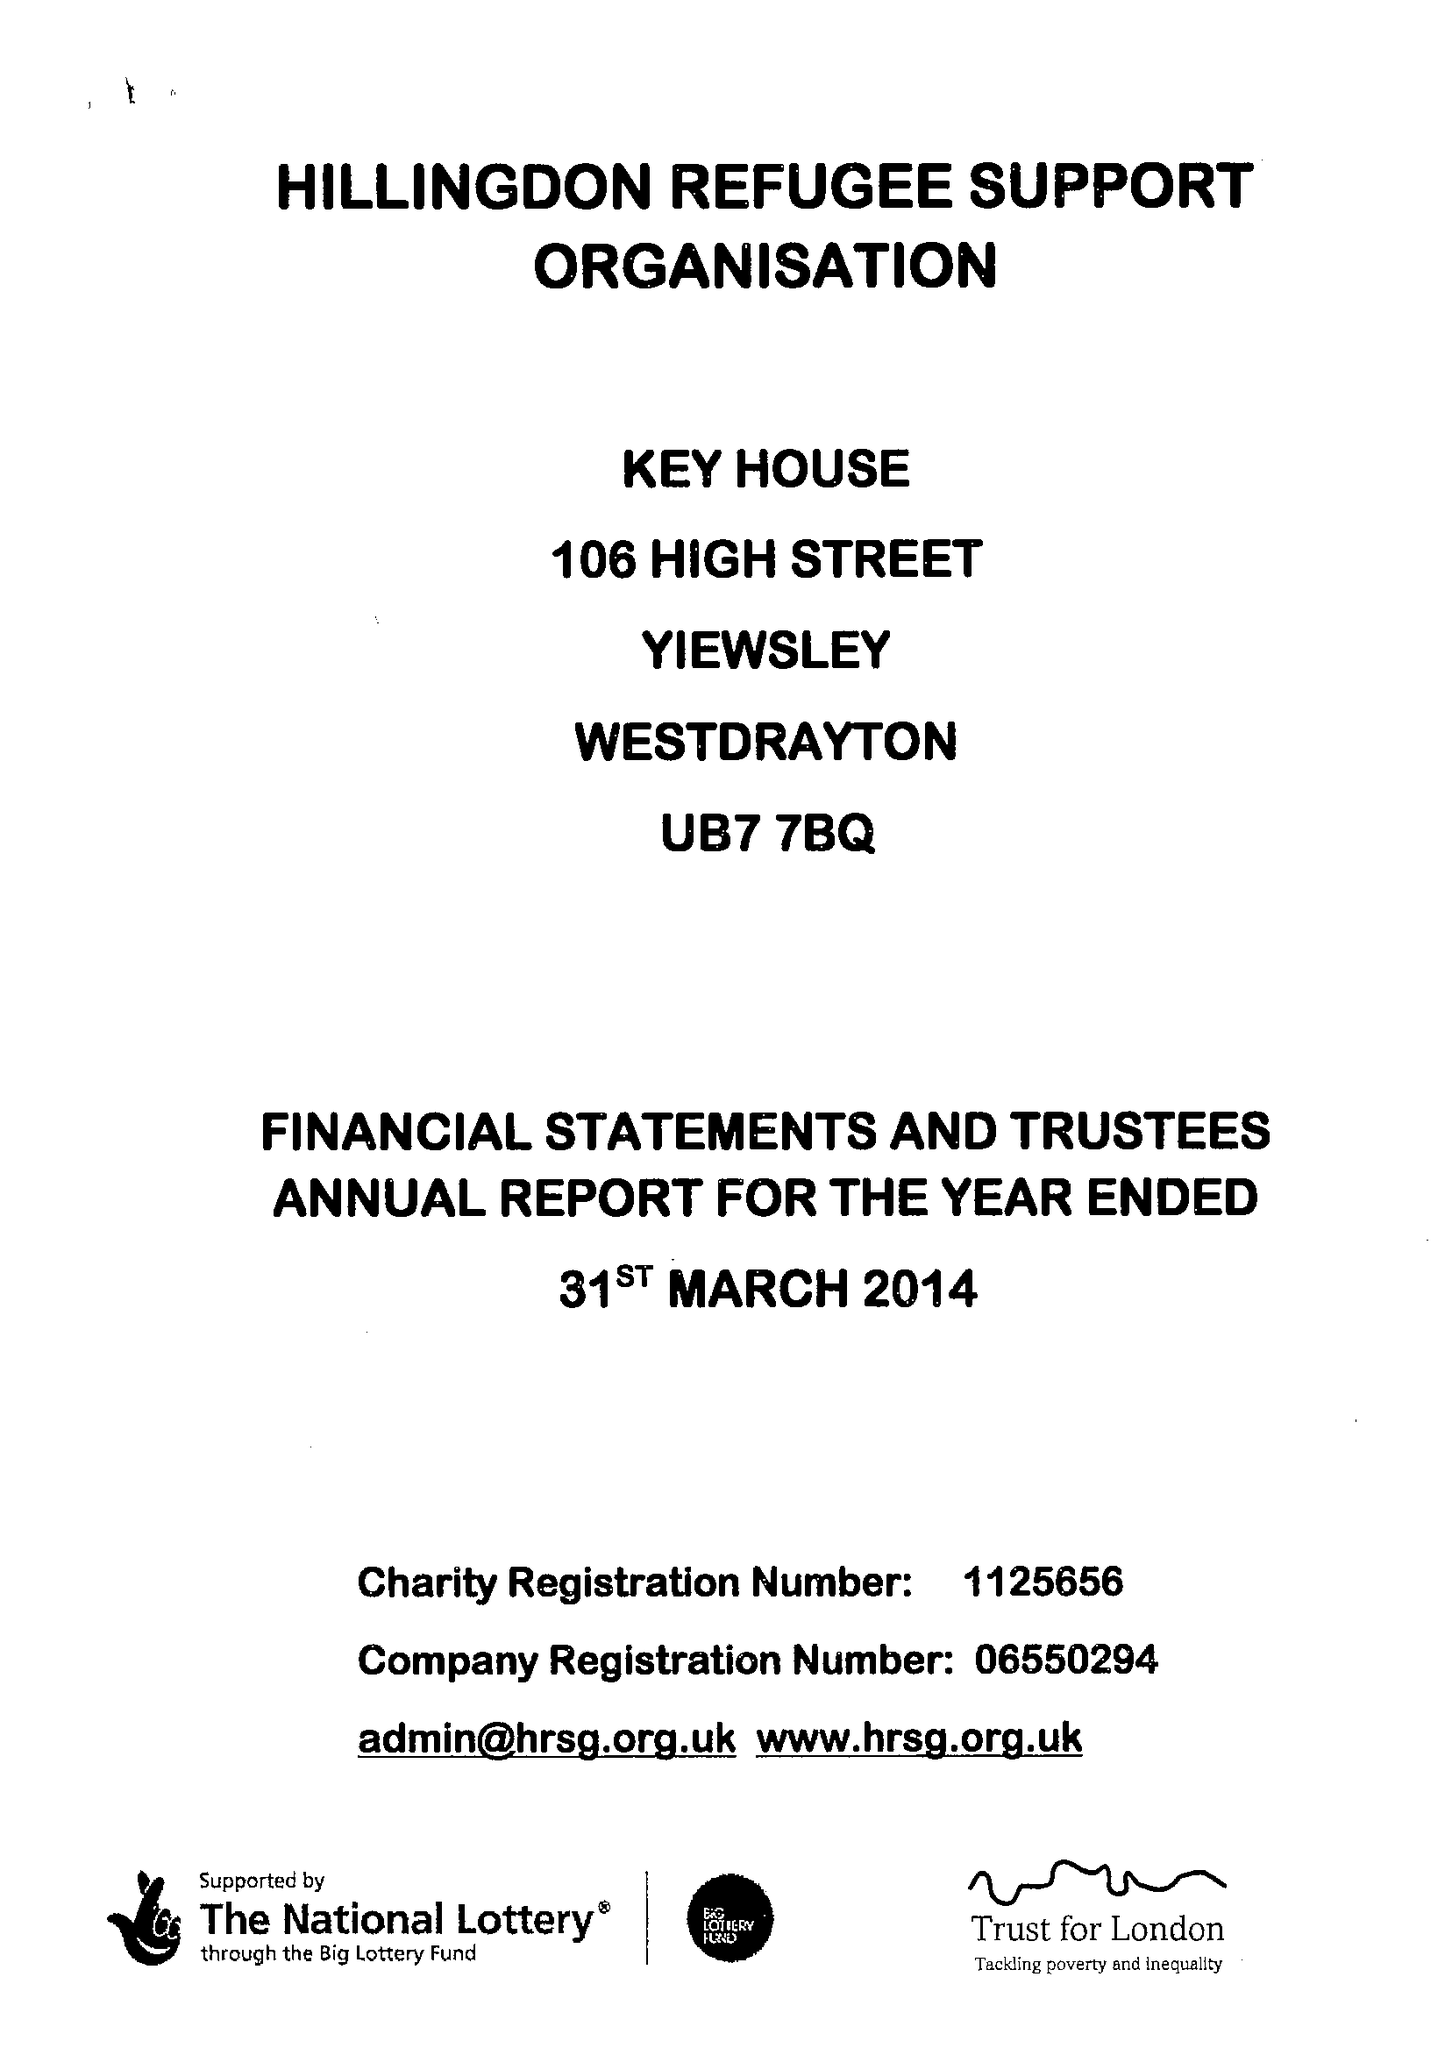What is the value for the income_annually_in_british_pounds?
Answer the question using a single word or phrase. 109358.00 